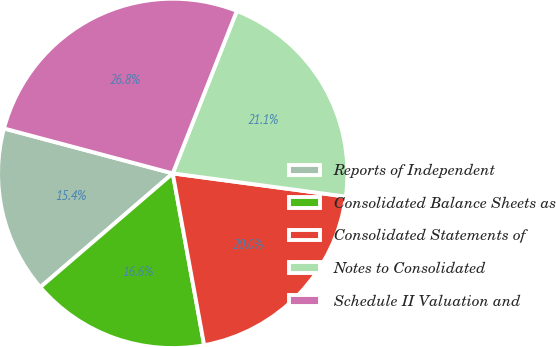Convert chart to OTSL. <chart><loc_0><loc_0><loc_500><loc_500><pie_chart><fcel>Reports of Independent<fcel>Consolidated Balance Sheets as<fcel>Consolidated Statements of<fcel>Notes to Consolidated<fcel>Schedule II Valuation and<nl><fcel>15.44%<fcel>16.58%<fcel>20.0%<fcel>21.14%<fcel>26.84%<nl></chart> 